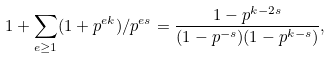Convert formula to latex. <formula><loc_0><loc_0><loc_500><loc_500>1 + \sum _ { e \geq 1 } ( 1 + p ^ { e k } ) / p ^ { e s } = \frac { 1 - p ^ { k - 2 s } } { ( 1 - p ^ { - s } ) ( 1 - p ^ { k - s } ) } ,</formula> 